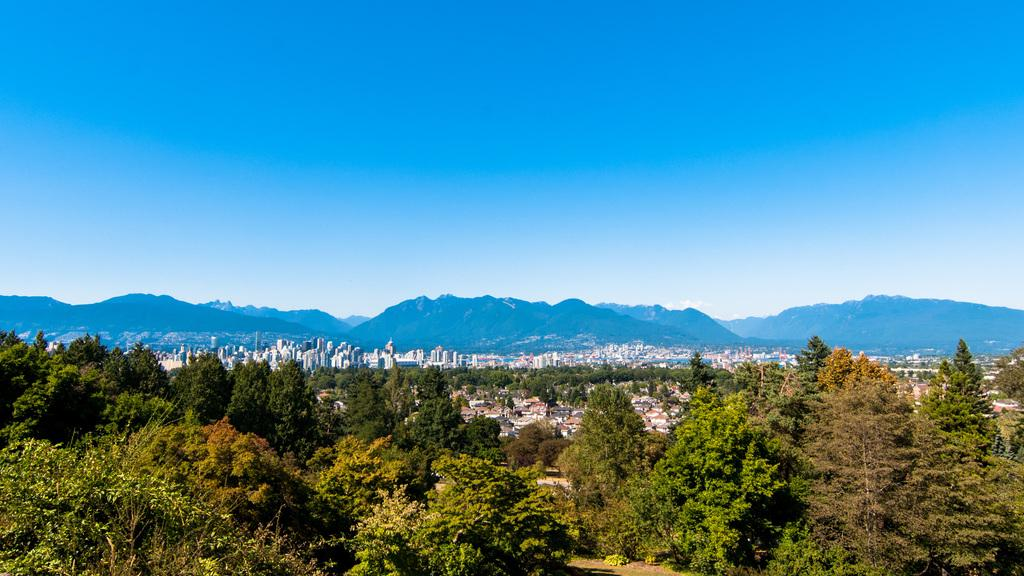What type of vegetation is present in the front of the image? There are trees in the front of the image. What type of structures can be seen in the background of the image? There are buildings in the background of the image. What type of natural landform is visible in the background of the image? There are hills in the background of the image. What is visible at the top of the image? The sky is visible at the top of the image. Is there an umbrella visible on the sidewalk in the image? There is no sidewalk or umbrella present in the image. Can you tell me how many items are in the pocket of the person in the image? There is no person or pocket visible in the image. 